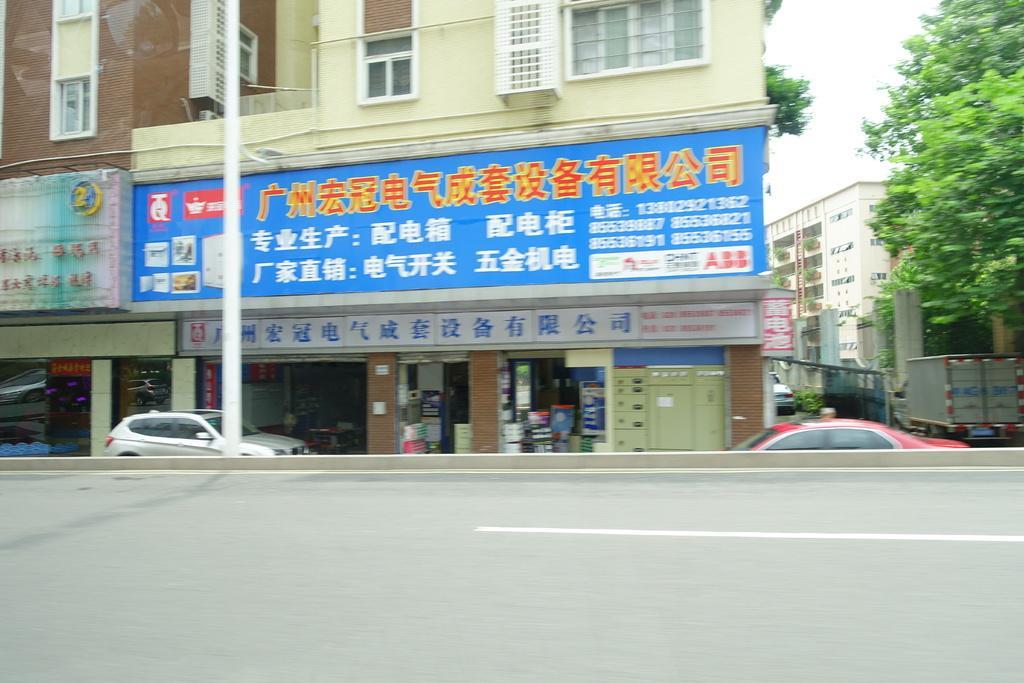In one or two sentences, can you explain what this image depicts? In this image we can see the buildings and also trees and vehicles. We can also see a pole, road and also the sky. 